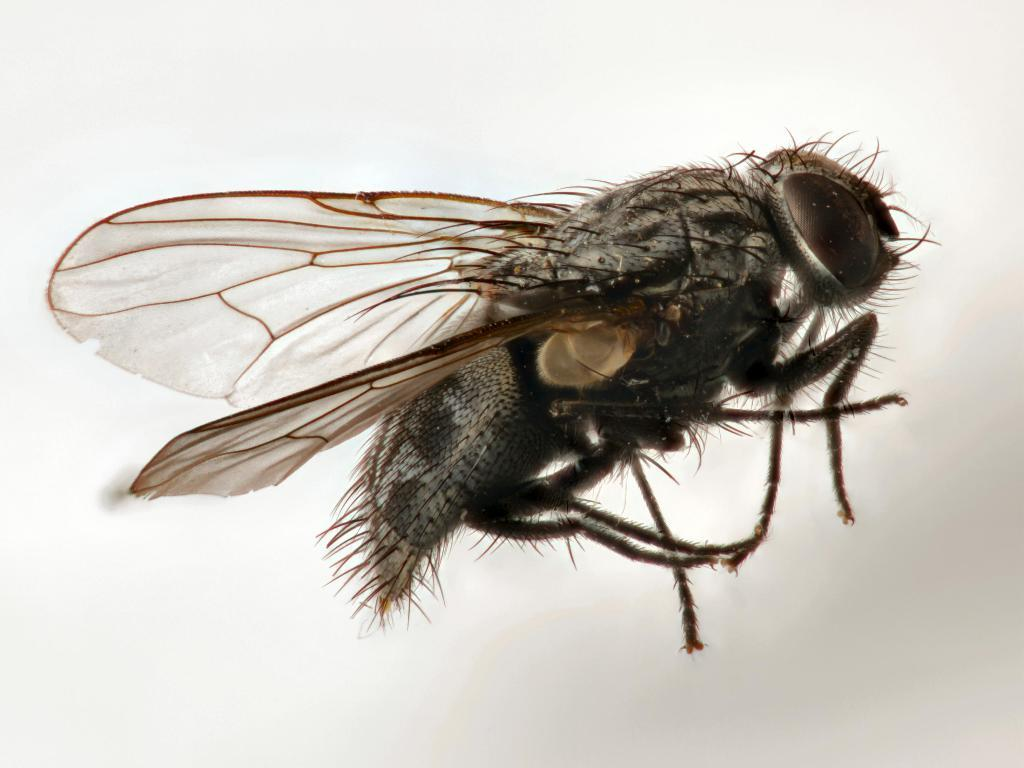What is present in the image? There is a fly in the image. In which direction is the fly facing? The fly is facing towards the right side. How does the fly measure the height of the hill in the image? There is no hill present in the image, and the fly is not measuring anything. 